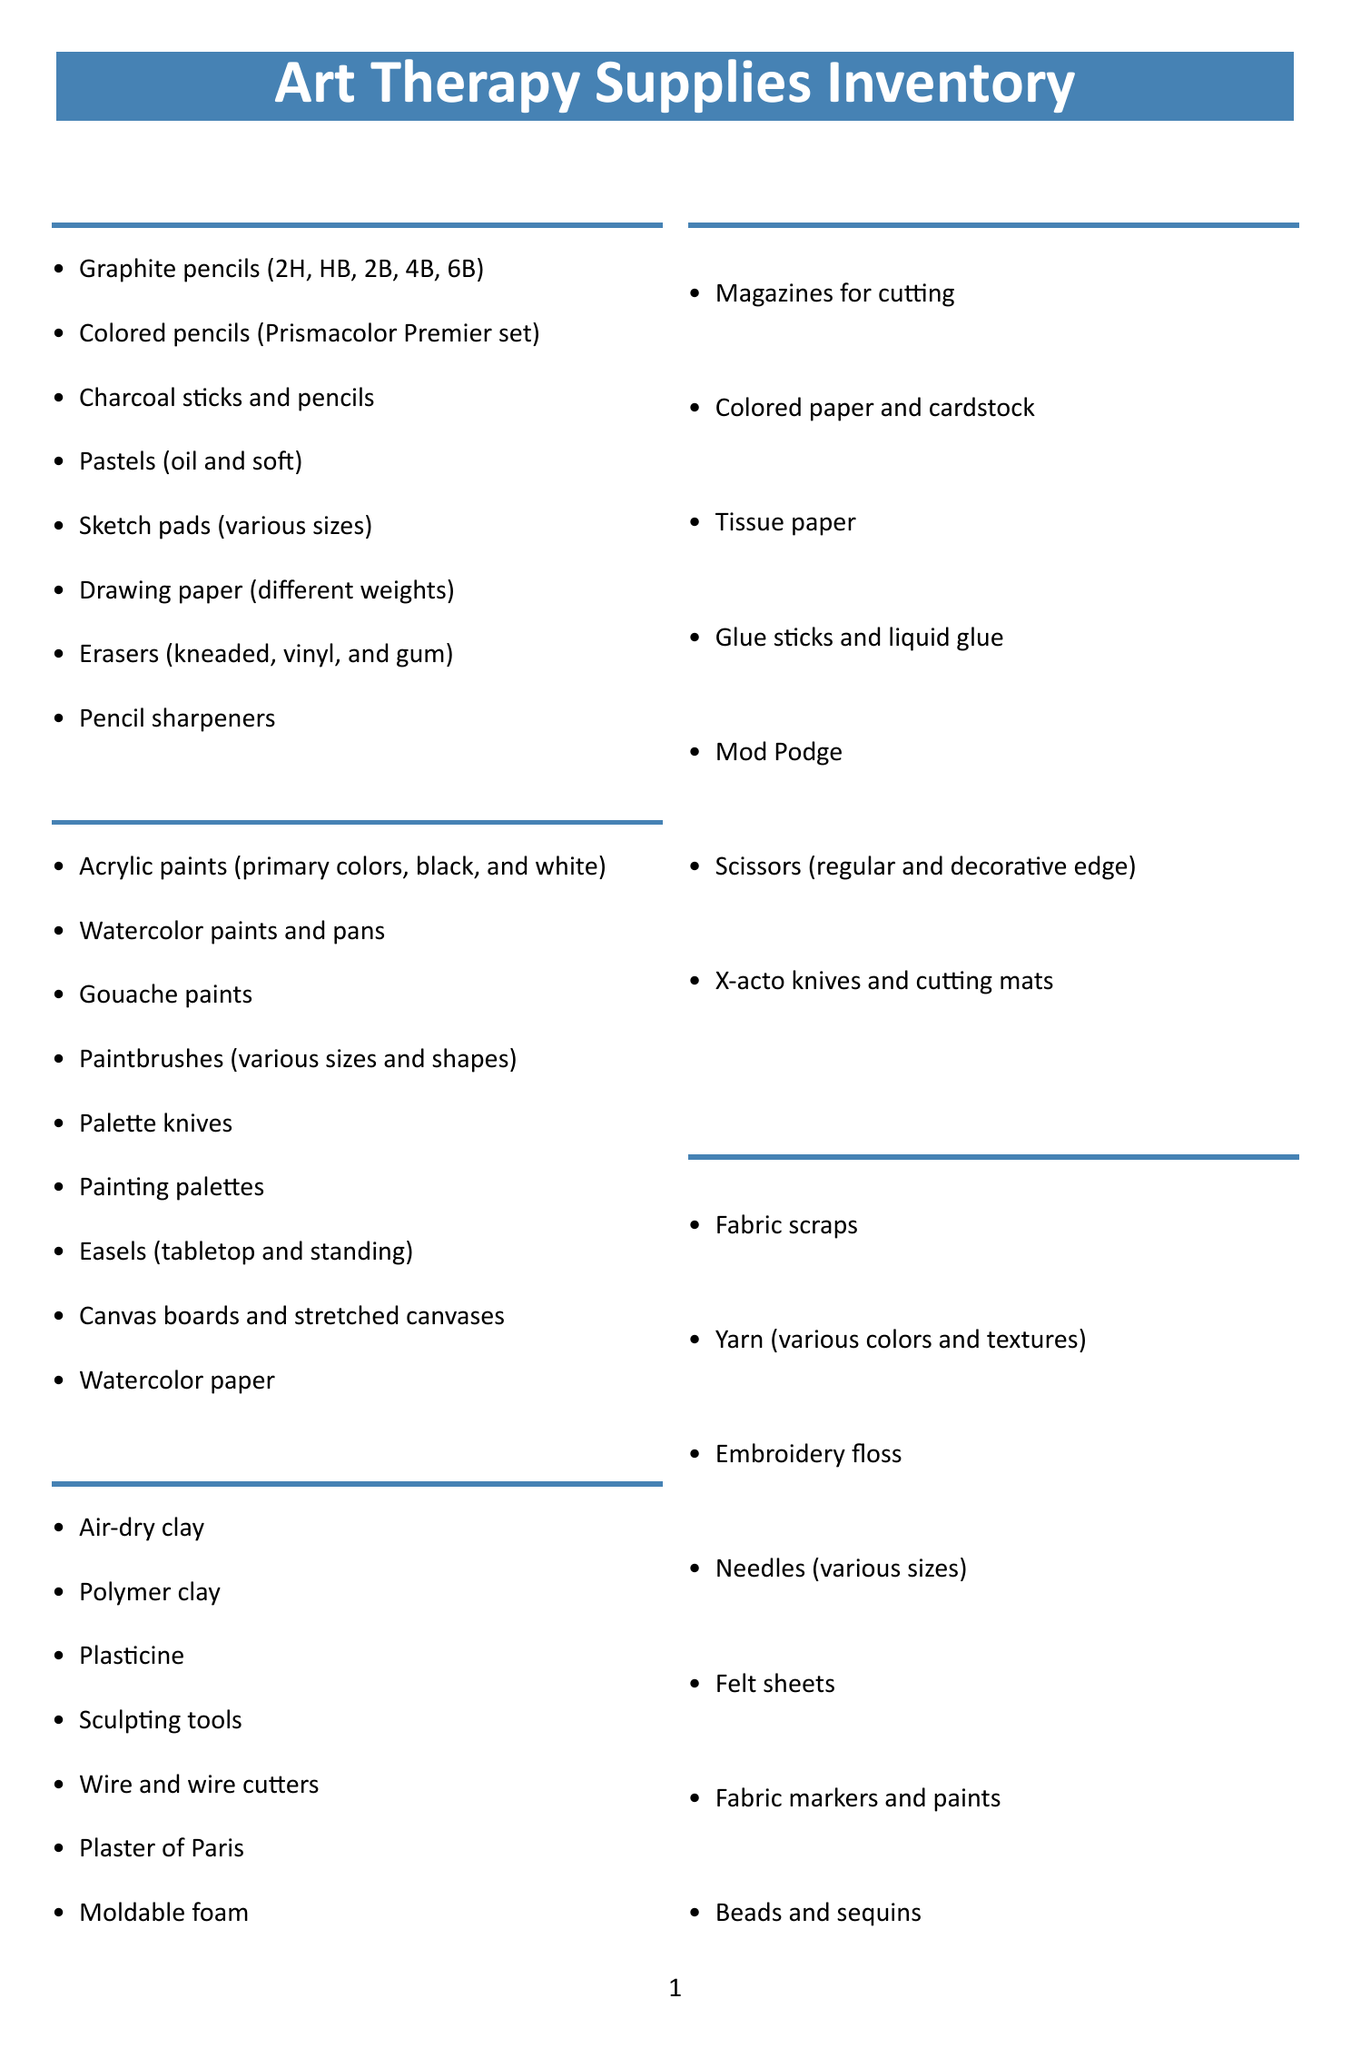What is the name of the checklist? The name of the checklist is specified at the beginning of the document.
Answer: Art Therapy Supplies Inventory How many categories are included in the checklist? The total number of categories listed in the checklist can be tallied.
Answer: 10 What item is listed under "Painting"? One of the items in the "Painting" category can be referenced for this answer.
Answer: Acrylic paints (primary colors, black, and white) Which category includes "Emotion face templates"? The category that contains this specific item can be identified from the document.
Answer: Emotion Expression Tools What supplies are listed for "Group Therapy Supplies"? The items available under the "Group Therapy Supplies" category can be reviewed for this question.
Answer: Large rolls of paper, Collaborative painting canvases, Group sculpting kits, Communal art journals, Mural-making materials Which item is required for mindfulness practice according to the list? The list highlights specific items that aid in mindfulness and relaxation.
Answer: Adult coloring books How many items are listed under "Sculpture and 3D Art"? The number of items in this category can be totaled from the document.
Answer: 7 What is one of the "Digital Art Supplies"? A specific item from the "Digital Art Supplies" category can provide the answer.
Answer: Drawing tablets What additional consideration involves restocking? The additional considerations section mentions specific needs related to supply management.
Answer: Reorder threshold 